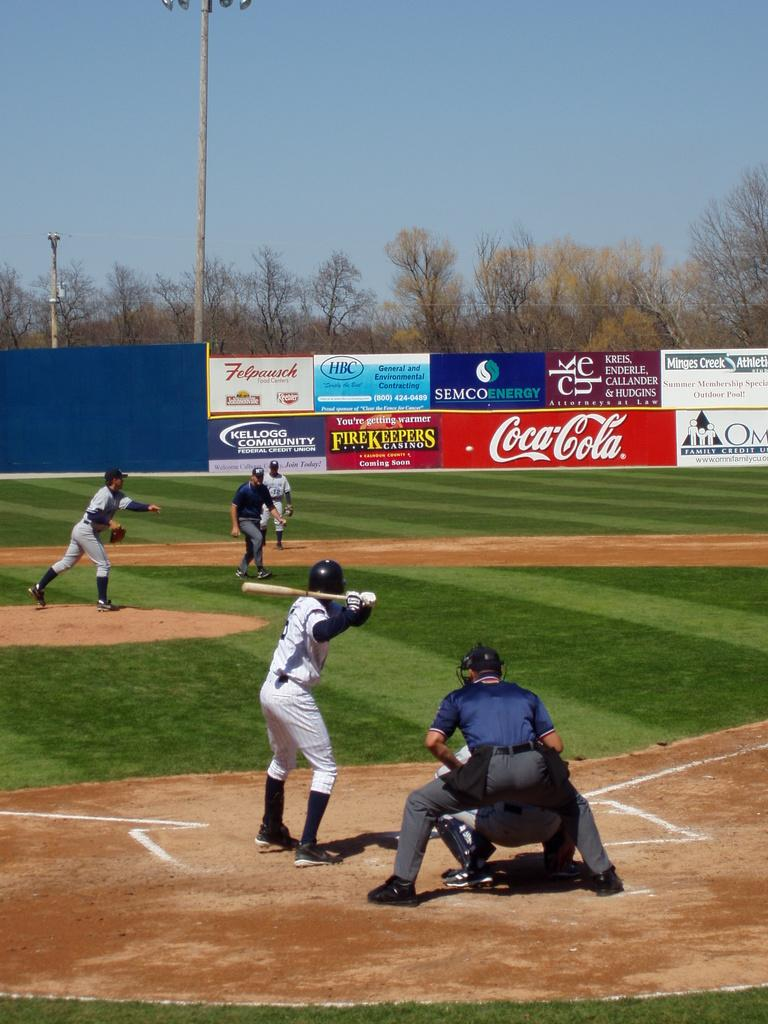<image>
Write a terse but informative summary of the picture. A baseball game being played with a Coca-Cola billboard in the background. 